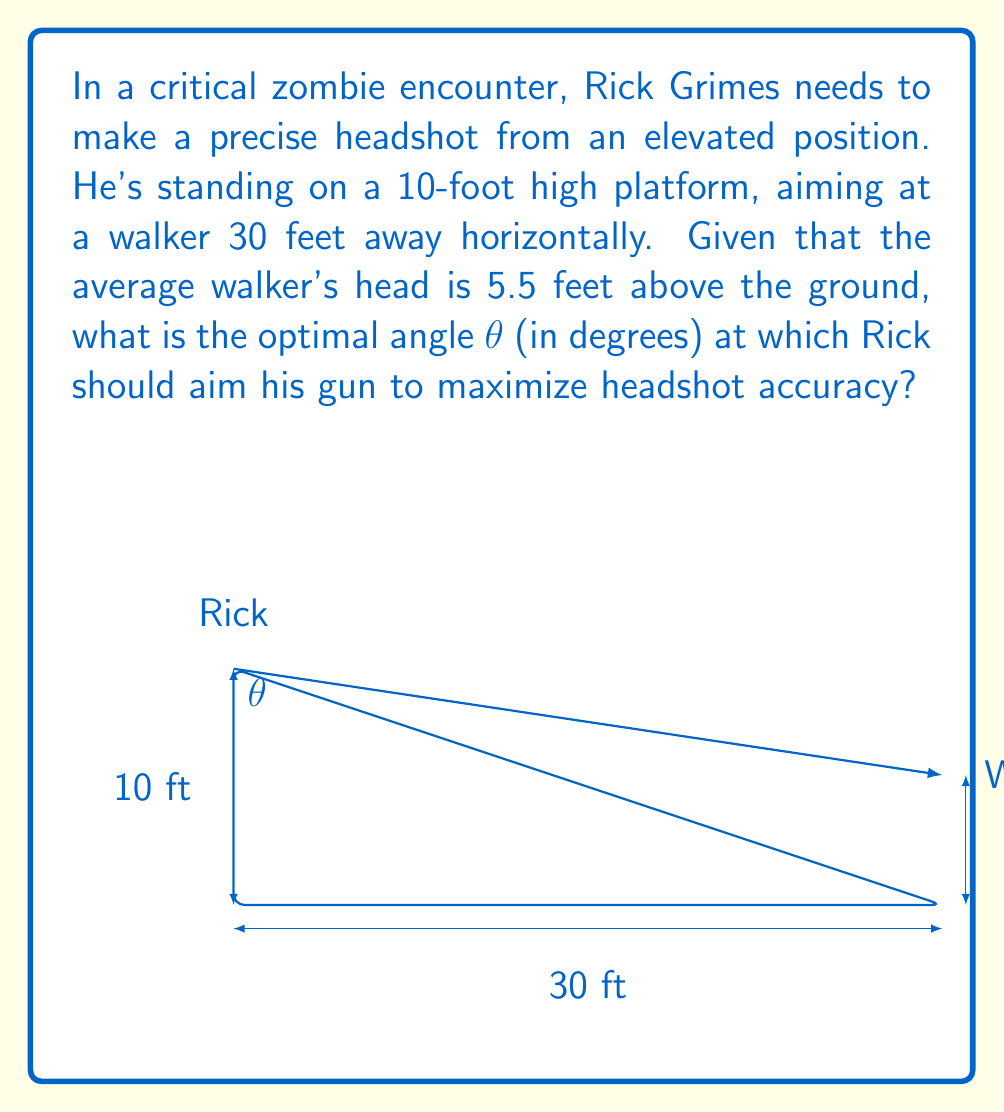Can you solve this math problem? Let's approach this step-by-step using trigonometry:

1) First, we need to find the vertical distance between Rick's position and the walker's head:
   $10 \text{ ft} - 5.5 \text{ ft} = 4.5 \text{ ft}$

2) Now we have a right triangle with:
   - Adjacent side (horizontal distance) = 30 ft
   - Opposite side (vertical distance) = 4.5 ft

3) To find the optimal angle θ, we use the tangent function:

   $$\tan(\theta) = \frac{\text{opposite}}{\text{adjacent}} = \frac{4.5}{30}$$

4) To solve for θ, we take the inverse tangent (arctan or $\tan^{-1}$):

   $$\theta = \tan^{-1}\left(\frac{4.5}{30}\right)$$

5) Calculate this value:

   $$\theta = \tan^{-1}(0.15) \approx 8.53°$$

6) Round to two decimal places for practical use.

Thus, Rick should aim his gun at approximately 8.53° below the horizontal to maximize headshot accuracy.
Answer: $8.53°$ 